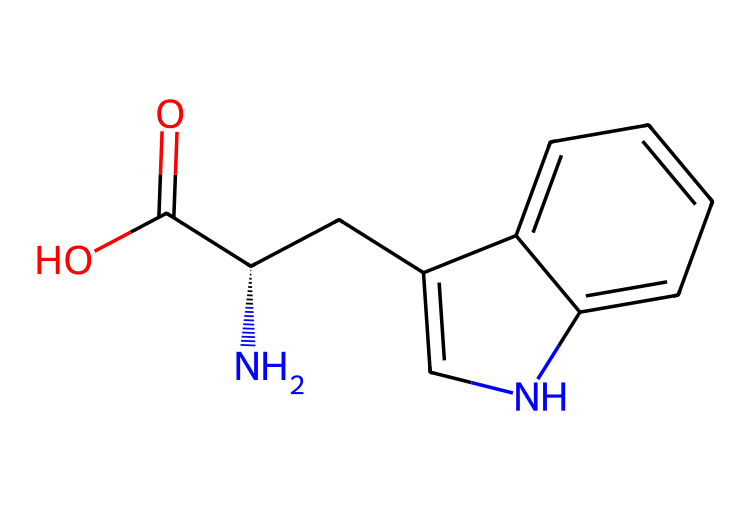What is the molecular formula of tryptophan? From the SMILES representation, we count the atoms present in the structure: 11 carbon atoms, 12 hydrogen atoms, 1 nitrogen atom, and 2 oxygen atoms. Therefore, the molecular formula is C11H12N2O2.
Answer: C11H12N2O2 How many nitrogen atoms are in tryptophan? Analyzing the SMILES string reveals one nitrogen in the amine group (N) and another in the pyrrole ring structure, totaling two nitrogen atoms in the molecular structure.
Answer: 2 What is the functional group present in tryptophan? The carboxylic acid group (–COOH) is evident from the C(=O)O notation in the SMILES, indicating the presence of this functional group, which is characteristic of amino acids.
Answer: carboxylic acid Does tryptophan contain a ring structure? The SMILES notation contains the cyclic part designated with C1=CNC2=CC=CC=C21, indicating that there is a fused ring structure involving nitrogen, confirming the presence of a cyclic component.
Answer: Yes What type of amino acid is tryptophan classified as? Tryptophan is classified as an aromatic amino acid due to its indole ring, which contains a benzene-like structure characterized by alternating double bonds, making it hydrophobic.
Answer: aromatic How does tryptophan influence mood and cognition? Tryptophan is a precursor to serotonin, a neurotransmitter associated with mood regulation. Analyzing its molecular structure helps understand its role in the biochemical synthesis of serotonin, hence influencing mood and cognition.
Answer: serotonin precursor What is the significance of the chiral center in tryptophan? The chiral center in tryptophan is the C@@H, which introduces stereoisomerism, affecting its biological interactions and function in proteins, essential for its role in various metabolic processes.
Answer: stereochemical significance 